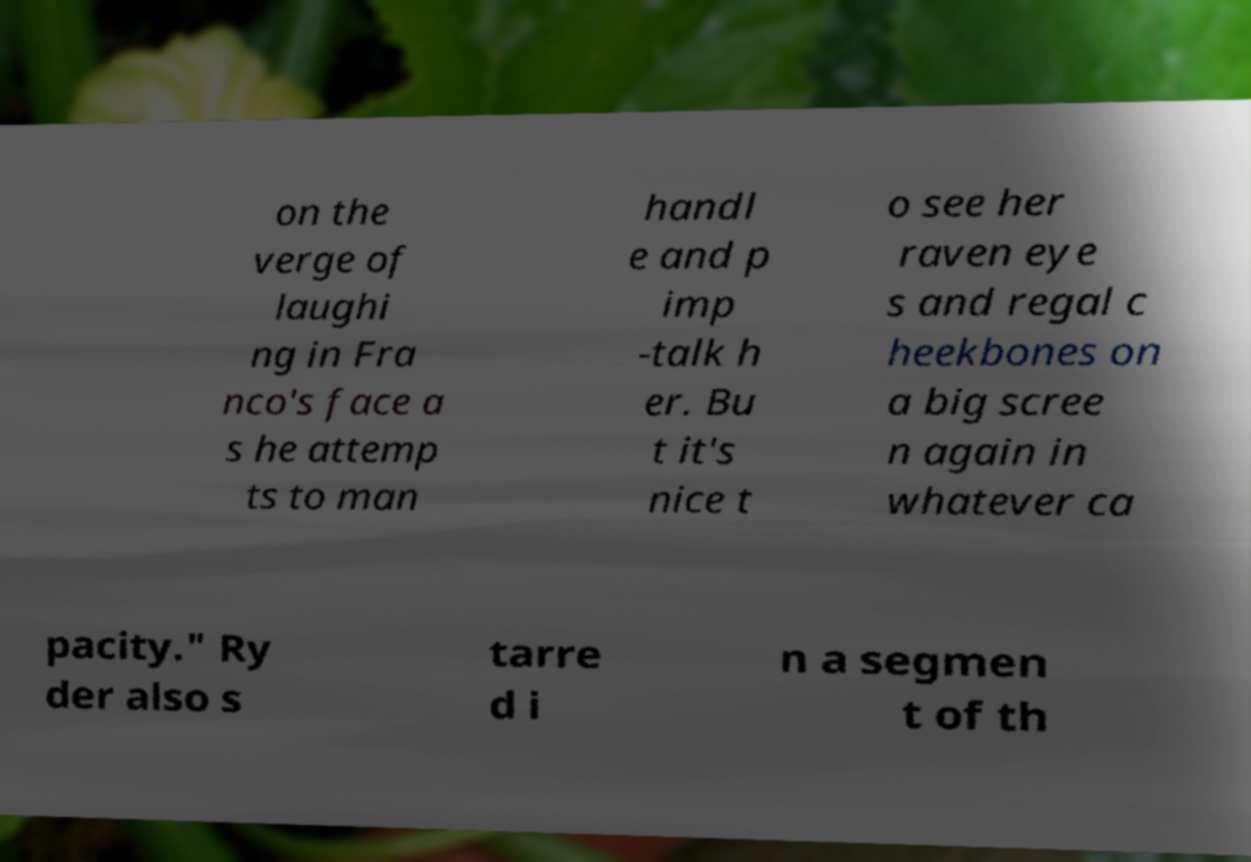Please identify and transcribe the text found in this image. on the verge of laughi ng in Fra nco's face a s he attemp ts to man handl e and p imp -talk h er. Bu t it's nice t o see her raven eye s and regal c heekbones on a big scree n again in whatever ca pacity." Ry der also s tarre d i n a segmen t of th 